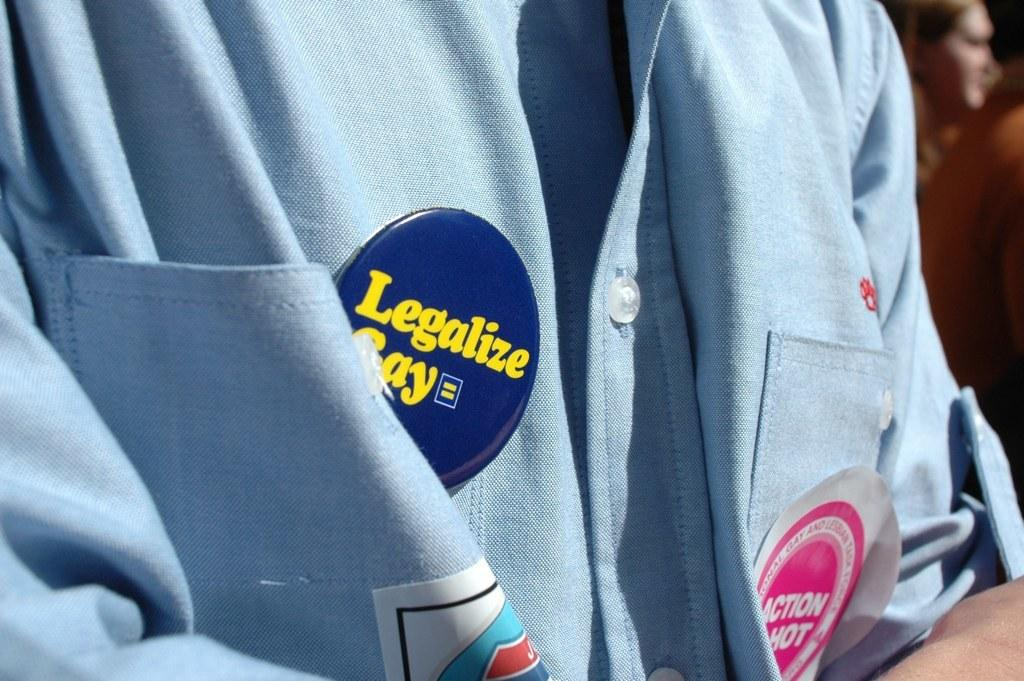Provide a one-sentence caption for the provided image. Someone wearing a blue shirt has a "Legalize Gay" button on to show solidarity. 